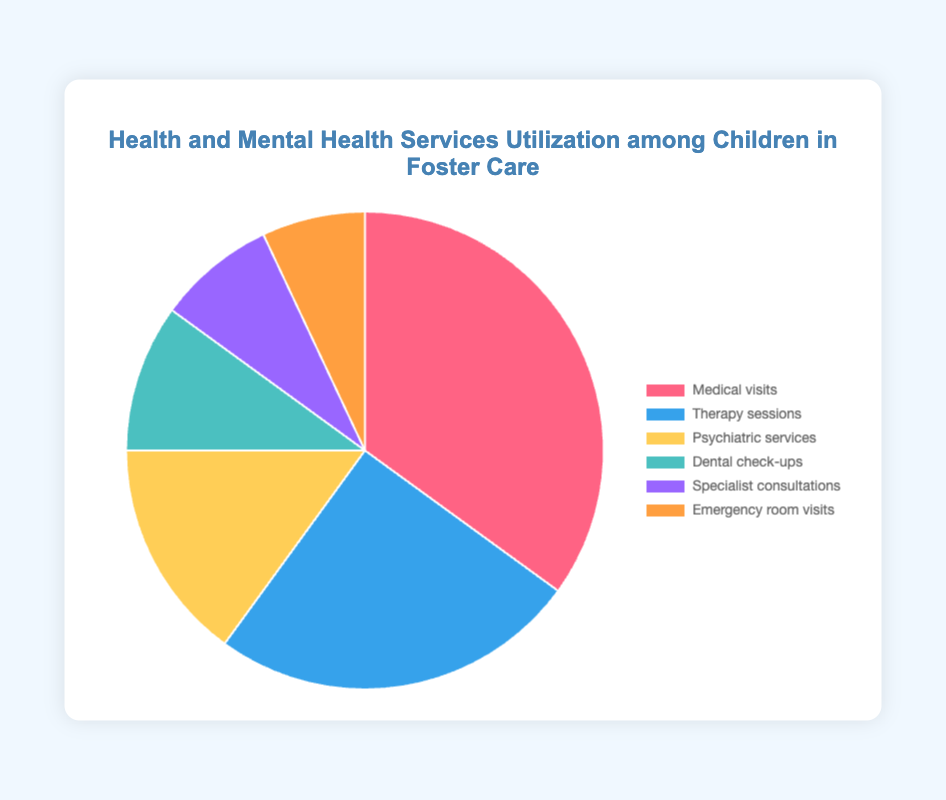Which service has the highest utilization percentage? Look at the pie chart and identify the segment with the largest size. According to the labels, "Medical visits" has the highest percentage at 35%.
Answer: Medical visits Which service has the lowest utilization percentage? Locate the smallest segment in the pie chart. According to the labels, "Emergency room visits" occupies the smallest portion at 7%.
Answer: Emergency room visits How much greater is the utilization of Medical visits compared to Psychiatric services? Medical visits are at 35% and Psychiatric services are at 15%. Subtract the smaller value from the larger: 35% - 15% = 20%.
Answer: 20% What is the total percentage of Therapy sessions and Dental check-ups combined? Sum the percentages of Therapy sessions (25%) and Dental check-ups (10%): 25% + 10% = 35%.
Answer: 35% Which service uses the blue segment in the pie chart? Identify the blue segment in the color legend. "Therapy sessions" are represented by the blue segment.
Answer: Therapy sessions Are there more Specialist consultations or Emergency room visits? Compare the percentages of Specialist consultations (8%) and Emergency room visits (7%). Since 8% is greater than 7%, there are more Specialist consultations.
Answer: Specialist consultations What is the average utilization percentage of Specialist consultations, Dental check-ups, and Emergency room visits? Sum the percentages of the three services: 8% (Specialist consultations) + 10% (Dental check-ups) + 7% (Emergency room visits) = 25%. Divide by the number of services: 25% / 3 ≈ 8.33%.
Answer: 8.33% Which service has exactly 10% utilization? Look at the pie chart to find the segment labeled with 10%. "Dental check-ups" have a utilization of 10%.
Answer: Dental check-ups How much more is the utilization of Medical visits compared to the combined utilization of Specialist consultations and Dental check-ups? Medical visits are at 35%. The combined utilization of Specialist consultations (8%) and Dental check-ups (10%) is 18%. Subtract the combined value from Medical visits: 35% - 18% = 17%.
Answer: 17% What is the combined percentage of all services related to mental health (Therapy sessions, Psychiatric services)? Sum the percentages of Therapy sessions (25%) and Psychiatric services (15%): 25% + 15% = 40%.
Answer: 40% 